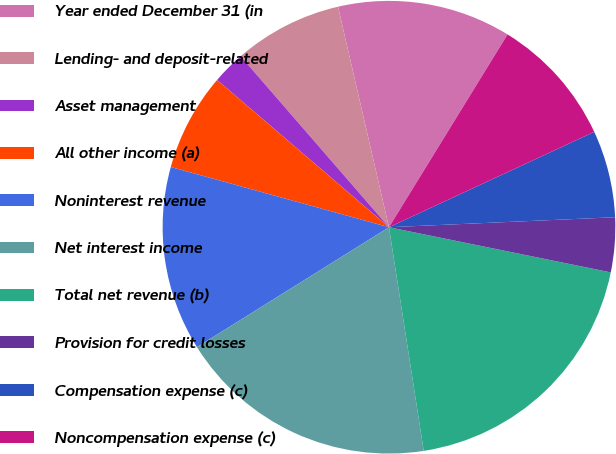<chart> <loc_0><loc_0><loc_500><loc_500><pie_chart><fcel>Year ended December 31 (in<fcel>Lending- and deposit-related<fcel>Asset management<fcel>All other income (a)<fcel>Noninterest revenue<fcel>Net interest income<fcel>Total net revenue (b)<fcel>Provision for credit losses<fcel>Compensation expense (c)<fcel>Noncompensation expense (c)<nl><fcel>12.39%<fcel>7.76%<fcel>2.35%<fcel>6.99%<fcel>13.17%<fcel>18.57%<fcel>19.35%<fcel>3.9%<fcel>6.22%<fcel>9.3%<nl></chart> 